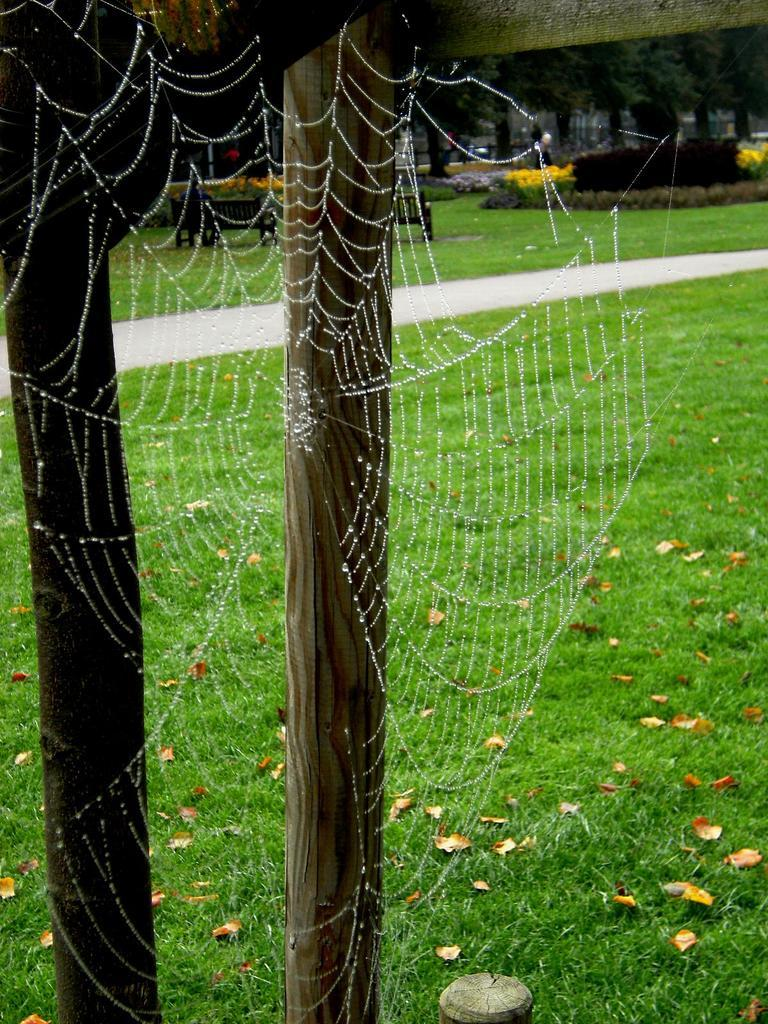What is present in the image that is related to a spider's habitat? There is a spider web in the image. What type of structures can be seen in the image? There are wooden poles in the image. What can be used for walking or traversing in the image? There is a pathway in the image. What type of vegetation is visible in the image? There is grass visible in the image. What type of seating is present in the background of the image? There are benches in the background of the image. What type of plants with colorful features can be seen in the background? There are plants with flowers in the background. What type of tall vegetation is present in the background? There are trees in the background. Can you tell me how many balloons are tied to the wooden poles in the image? There are no balloons present in the image; it features a spider web, wooden poles, a pathway, grass, benches, plants with flowers, and trees. What type of watch is visible on the spider's leg in the image? There are no watches present in the image, as it features a spider web and not a spider with a watch. 